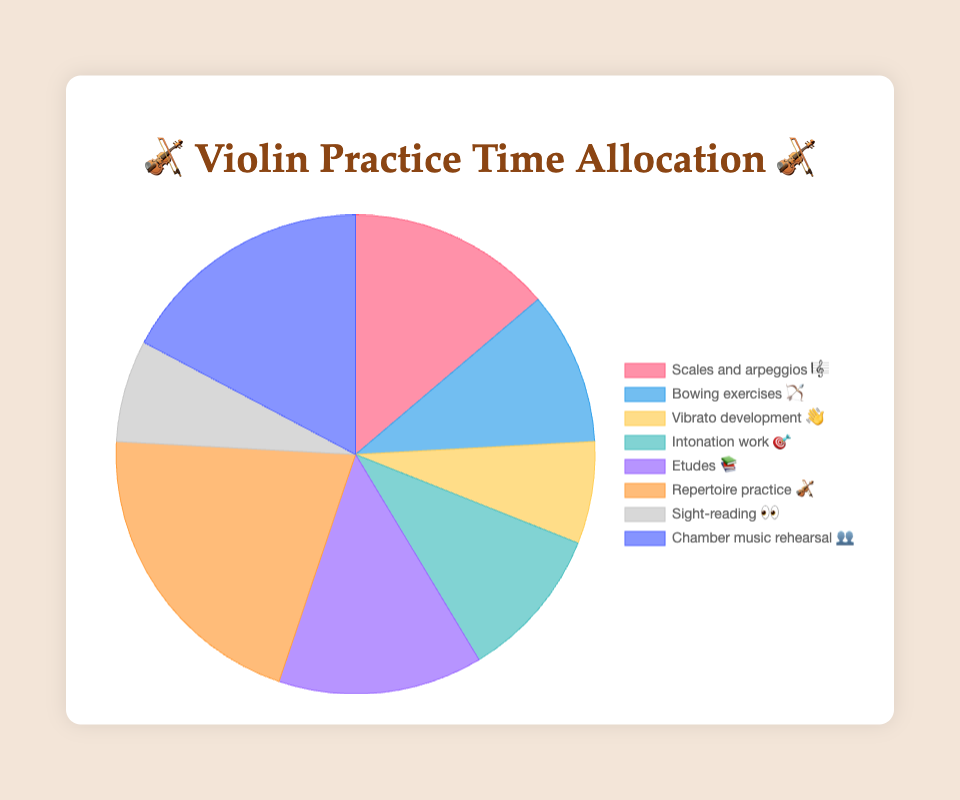Which technique has the highest time allocation? The technique with the highest time allocation can be found by identifying the largest segment in the pie chart.
Answer: Repertoire practice 🎻 What is the total time allocated to bowing exercises 🏹 and intonation work 🎯? Bowing exercises have 15 minutes and intonation work also has 15 minutes. Adding these together gives 15 + 15 = 30 minutes.
Answer: 30 minutes Which two techniques have the same time allocation? By examining the segments, we see that scales and arpeggios 🎼, and etudes 📚 each have a 20-minute allocation.
Answer: Scales and arpeggios 🎼 and Etudes 📚 What is the difference in time allocation between repertoire practice 🎻 and sight-reading 👀? Repertoire practice is allocated 30 minutes, and sight-reading is allocated 10 minutes. The difference is 30 - 10 = 20 minutes.
Answer: 20 minutes How many techniques are allocated more than 20 minutes of practice? Repertoire practice 🎻 (30 minutes) and chamber music rehearsal 👥 (25 minutes) are both allocated more than 20 minutes each. There are 2 techniques in total.
Answer: 2 techniques What is the average time allocation across all techniques? Sum the time allocations: 20 + 15 + 10 + 15 + 20 + 30 + 10 + 25 = 145 minutes. Divide by the number of techniques, which is 8. 145 / 8 = 18.125 minutes.
Answer: 18.125 minutes Which technique requires the least amount of practice time? The technique with the smallest segment in the pie chart corresponds to the one with the smallest time allocation, which is vibrato development 👋 and sight-reading 👀, each allocated 10 minutes.
Answer: Vibrato development 👋 and Sight-reading 👀 What percentage of the total practice time is allocated to chamber music rehearsal 👥? The total practice time is 145 minutes. Chamber music rehearsal is allocated 25 minutes. The percentage is (25 / 145) * 100 ≈ 17.24%.
Answer: 17.24% Is the time allocated for scales and arpeggios 🎼 higher than that for bowing exercises 🏹? Scales and arpeggios are allocated 20 minutes, while bowing exercises are allocated 15 minutes. 20 is greater than 15.
Answer: Yes 